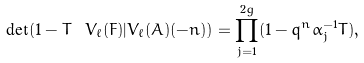<formula> <loc_0><loc_0><loc_500><loc_500>\det ( 1 - T \ V _ { \ell } ( F ) | V _ { \ell } ( A ) ( - n ) ) = \prod _ { j = 1 } ^ { 2 g } ( 1 - q ^ { n } \alpha _ { j } ^ { - 1 } T ) ,</formula> 